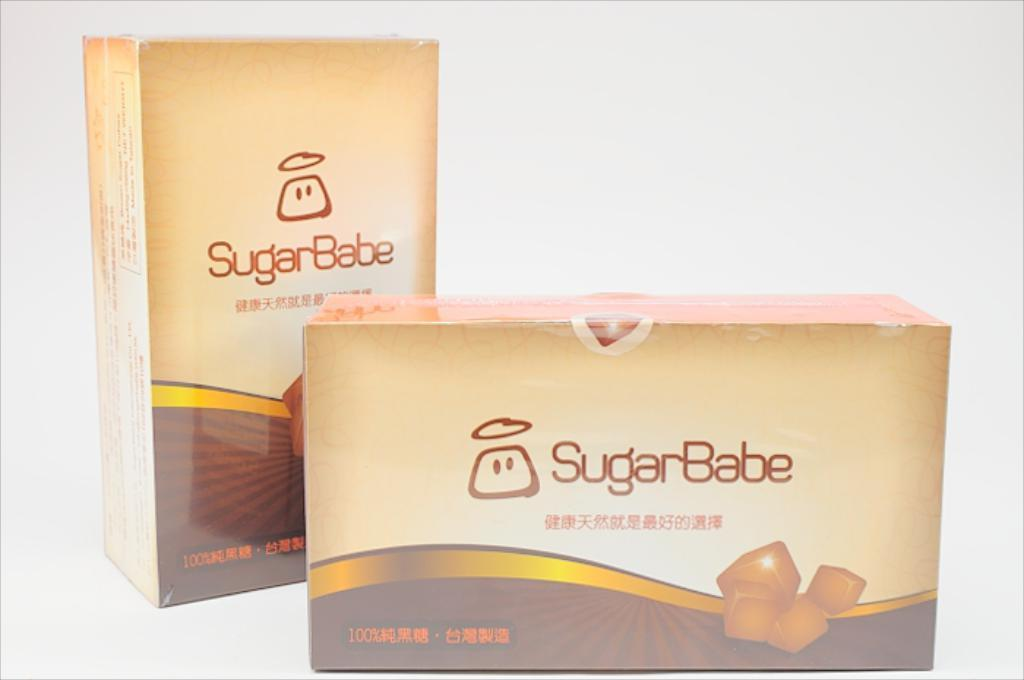<image>
Write a terse but informative summary of the picture. A Sugarbabe snack sitting next to another one. 